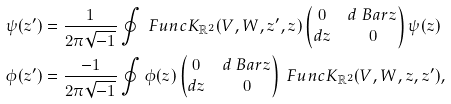<formula> <loc_0><loc_0><loc_500><loc_500>\psi ( z ^ { \prime } ) & = \frac { 1 } { 2 \pi \sqrt { - 1 } } \oint \ F u n c { K } _ { \mathbb { R } ^ { 2 } } ( V , W , z ^ { \prime } , z ) \begin{pmatrix} 0 & d \ B a r { z } \\ d z & 0 \end{pmatrix} \psi ( z ) \\ \phi ( z ^ { \prime } ) & = \frac { - 1 } { 2 \pi \sqrt { - 1 } } \oint \phi ( z ) \begin{pmatrix} 0 & d \ B a r { z } \\ d z & 0 \end{pmatrix} \ F u n c { K } _ { \mathbb { R } ^ { 2 } } ( V , W , z , z ^ { \prime } ) ,</formula> 